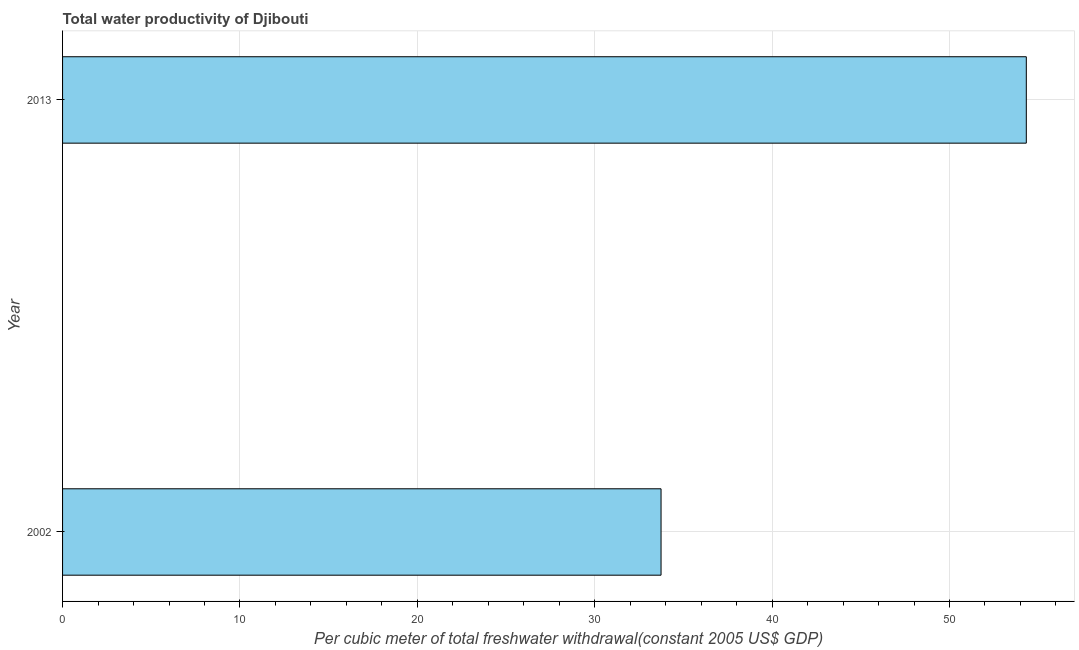Does the graph contain grids?
Keep it short and to the point. Yes. What is the title of the graph?
Your response must be concise. Total water productivity of Djibouti. What is the label or title of the X-axis?
Keep it short and to the point. Per cubic meter of total freshwater withdrawal(constant 2005 US$ GDP). What is the total water productivity in 2013?
Provide a short and direct response. 54.33. Across all years, what is the maximum total water productivity?
Provide a short and direct response. 54.33. Across all years, what is the minimum total water productivity?
Your answer should be very brief. 33.74. What is the sum of the total water productivity?
Provide a short and direct response. 88.07. What is the difference between the total water productivity in 2002 and 2013?
Make the answer very short. -20.59. What is the average total water productivity per year?
Give a very brief answer. 44.03. What is the median total water productivity?
Your answer should be compact. 44.03. Do a majority of the years between 2002 and 2013 (inclusive) have total water productivity greater than 34 US$?
Keep it short and to the point. No. What is the ratio of the total water productivity in 2002 to that in 2013?
Provide a short and direct response. 0.62. Are all the bars in the graph horizontal?
Offer a terse response. Yes. Are the values on the major ticks of X-axis written in scientific E-notation?
Give a very brief answer. No. What is the Per cubic meter of total freshwater withdrawal(constant 2005 US$ GDP) of 2002?
Offer a very short reply. 33.74. What is the Per cubic meter of total freshwater withdrawal(constant 2005 US$ GDP) of 2013?
Offer a terse response. 54.33. What is the difference between the Per cubic meter of total freshwater withdrawal(constant 2005 US$ GDP) in 2002 and 2013?
Your answer should be very brief. -20.59. What is the ratio of the Per cubic meter of total freshwater withdrawal(constant 2005 US$ GDP) in 2002 to that in 2013?
Your response must be concise. 0.62. 